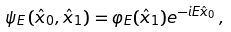<formula> <loc_0><loc_0><loc_500><loc_500>\psi _ { E } \left ( \hat { x } _ { 0 } , \hat { x } _ { 1 } \right ) = \varphi _ { E } ( \hat { x } _ { 1 } ) e ^ { - i E \hat { x } _ { 0 } } \, ,</formula> 